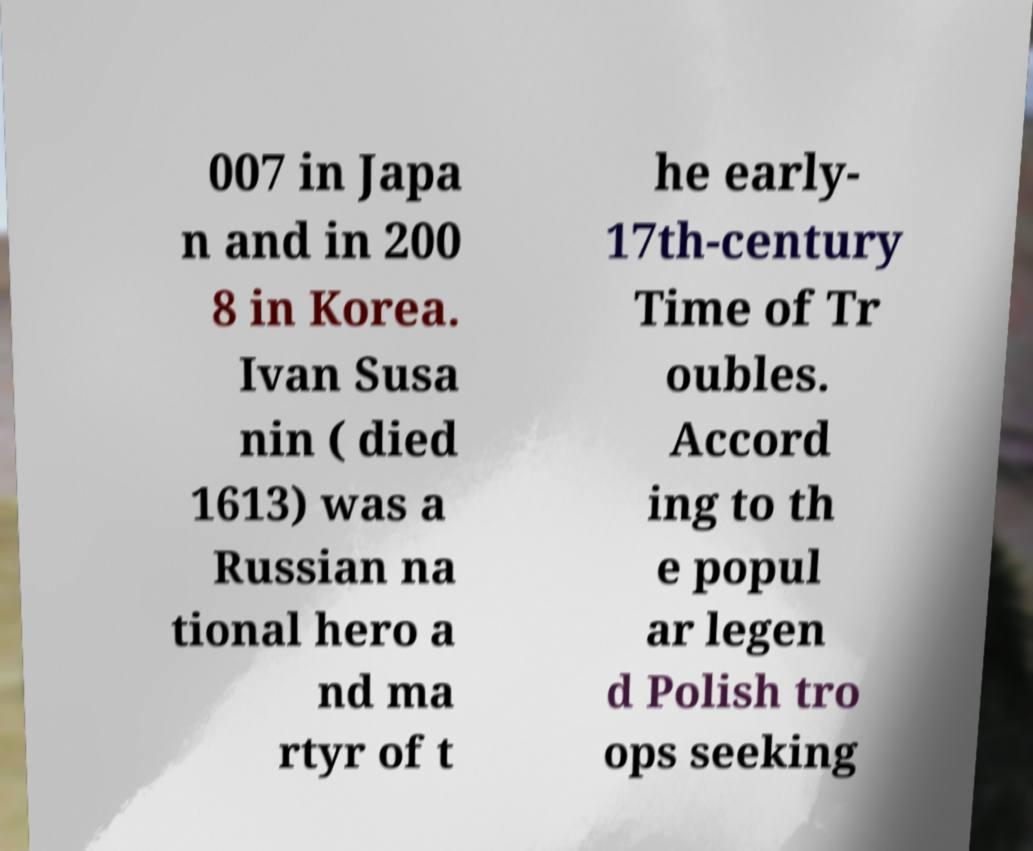Could you assist in decoding the text presented in this image and type it out clearly? 007 in Japa n and in 200 8 in Korea. Ivan Susa nin ( died 1613) was a Russian na tional hero a nd ma rtyr of t he early- 17th-century Time of Tr oubles. Accord ing to th e popul ar legen d Polish tro ops seeking 